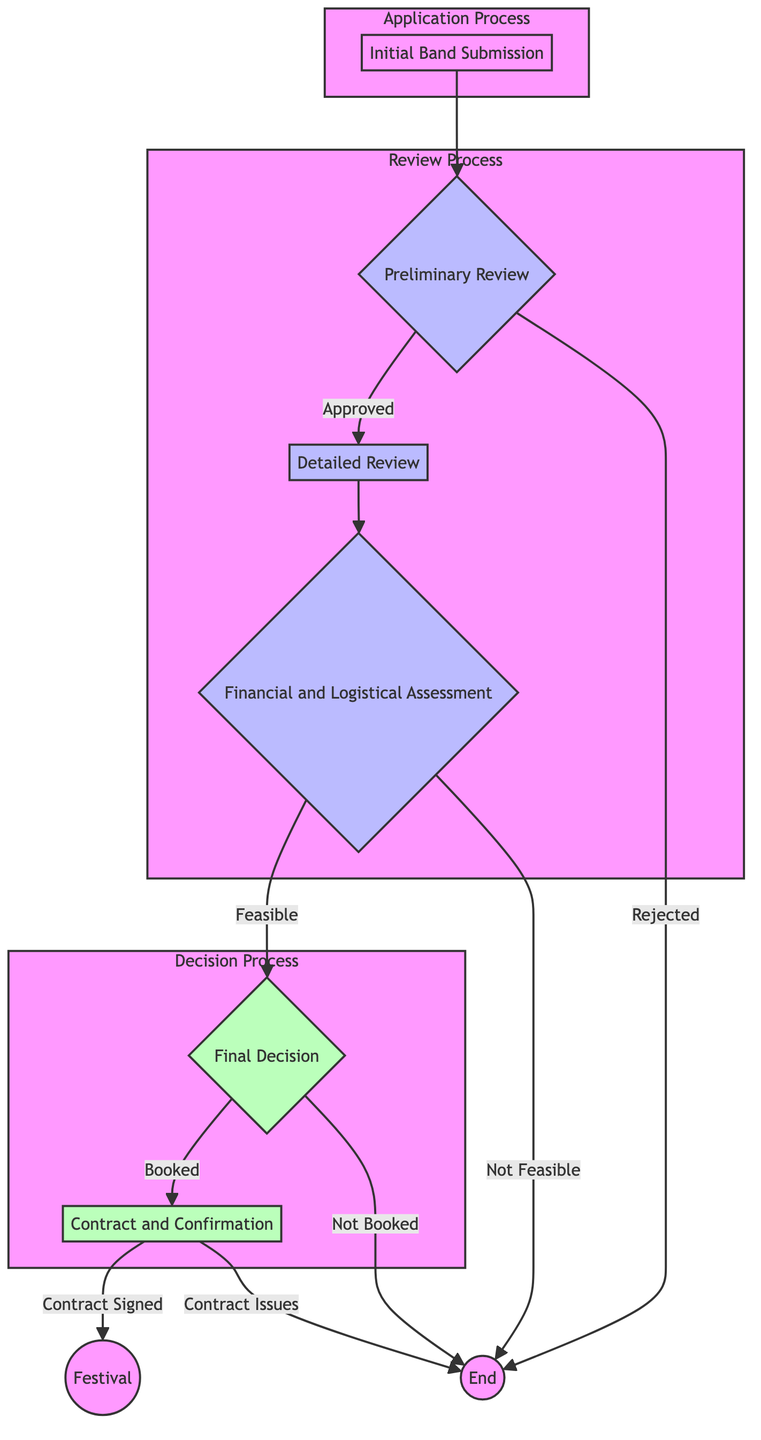What is the first stage in the band vetting process? The first stage listed in the diagram is "Initial Band Submission," where bands submit their applications along with relevant materials.
Answer: Initial Band Submission Which team conducts the preliminary review of applications? The diagram indicates that the "Review Team" is responsible for conducting the preliminary review of applications.
Answer: Review Team What happens if a band is rejected in the preliminary review? According to the diagram, if a band is rejected at this stage, the process ends, leading to "End."
Answer: End What are the two possible outcomes of the detailed review? The detailed review can result in either being "Shortlisted" or "Rejected," as specified in the flowchart.
Answer: Shortlisted, Rejected What criteria does the financial and logistical assessment use? The assessment considers "Budget Fit," "Travel Logistics," and "Technical Requirements" as its criteria.
Answer: Budget Fit, Travel Logistics, Technical Requirements How many outcomes are possible in the final decision stage? In the final decision stage, there are two potential outcomes: "Booked" and "Not Booked," meaning the curator can either book the band or not.
Answer: 2 What is required after a band is booked? After a band is booked, the process moves to "Contract and Confirmation," where contracts are sent and signed by the band.
Answer: Contract and Confirmation What stage follows the financial and logistical assessment if the assessment is feasible? If the financial and logistical assessment is determined to be feasible, the next stage is the "Final Decision."
Answer: Final Decision Which teams are involved in the financial and logistical assessment? The diagram shows that the "Finance Team" and "Logistics Team" are involved in this assessment.
Answer: Finance Team, Logistics Team 